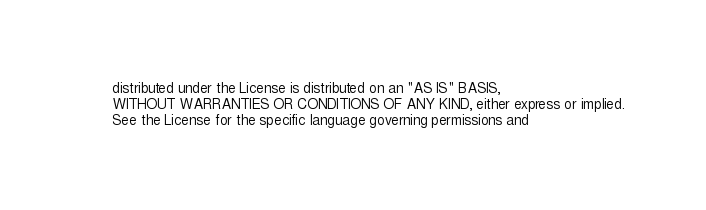Convert code to text. <code><loc_0><loc_0><loc_500><loc_500><_XML_>    distributed under the License is distributed on an "AS IS" BASIS,
    WITHOUT WARRANTIES OR CONDITIONS OF ANY KIND, either express or implied.
    See the License for the specific language governing permissions and</code> 